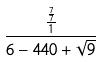Convert formula to latex. <formula><loc_0><loc_0><loc_500><loc_500>\frac { \frac { \frac { 7 } { 7 } } { 1 } } { 6 - 4 4 0 + \sqrt { 9 } }</formula> 